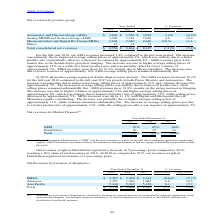According to Stmicroelectronics's financial document, In 2019, what was the reason for increase in ADG revenues? The increase was primarily due to improved average selling prices of approximately 9%, which was entirely due to a better product mix, and partially offset by a decrease in volumes by approximately 8%.. The document states: "es increased 1.4% compared to the previous period. The increase was primarily due to improved average selling prices of approximately 9%, which was en..." Also, In 2019, what was the reason for increase in AMS revenues? AMS revenues grew 4.6%, mainly due to the double-digits growth in Imaging. The increase was due to higher average selling prices of approximately 12%, as a result of a better product mix, and was partially offset by lower volumes of approximately 7%.. The document states: "fset by a decrease in volumes by approximately 8%. AMS revenues grew 4.6%, mainly due to the double-digits growth in Imaging. The increase was due to ..." Also, In 2019, what was the reason for fall in MDG revenues? MDG revenues were down by 10.3%, mainly due to Microcontrollers. The decrease was due to lower volumes of approximately 10% while average selling prices remained substantially flat.. The document states: "ially offset by lower volumes of approximately 7%. MDG revenues were down by 10.3%, mainly due to Microcontrollers. The decrease was due to lower volu..." Also, can you calculate: What are the average net revenues by Automotive and Discrete Group (ADG)? To answer this question, I need to perform calculations using the financial data. The calculation is: (3,606+3,556+3,059) / 3, which equals 3407 (in millions). This is based on the information: "Automotive and Discrete Group (ADG) $ 3,606 $ 3,556 $ 3,059 1.4% 16.2% Automotive and Discrete Group (ADG) $ 3,606 $ 3,556 $ 3,059 1.4% 16.2% motive and Discrete Group (ADG) $ 3,606 $ 3,556 $ 3,059 1...." The key data points involved are: 3,059, 3,556, 3,606. Also, can you calculate: What are the average net revenues by Analog MEMS and Sensors Group (AMS)? To answer this question, I need to perform calculations using the financial data. The calculation is: (3,299+3,154+2,630) / 3, which equals 3027.67 (in millions). This is based on the information: "Analog MEMS and Sensors Group (AMS) 3,299 3,154 2,630 4.6 19.9 Analog MEMS and Sensors Group (AMS) 3,299 3,154 2,630 4.6 19.9 Analog MEMS and Sensors Group (AMS) 3,299 3,154 2,630 4.6 19.9..." The key data points involved are: 2,630, 3,154, 3,299. Also, can you calculate: What are the average net revenues by Microcontrollers and Digital ICs Group (MDG)? To answer this question, I need to perform calculations using the financial data. The calculation is: (2,638+2,940+2,646) / 3, which equals 2741.33 (in millions). This is based on the information: "ntrollers and Digital ICs Group (MDG) 2,638 2,940 2,646 (10.3) 11.1 Microcontrollers and Digital ICs Group (MDG) 2,638 2,940 2,646 (10.3) 11.1 icrocontrollers and Digital ICs Group (MDG) 2,638 2,940 2..." The key data points involved are: 2,638, 2,646, 2,940. 